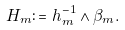<formula> <loc_0><loc_0><loc_500><loc_500>H _ { m } \colon = h _ { m } ^ { - 1 } \wedge \beta _ { m } .</formula> 